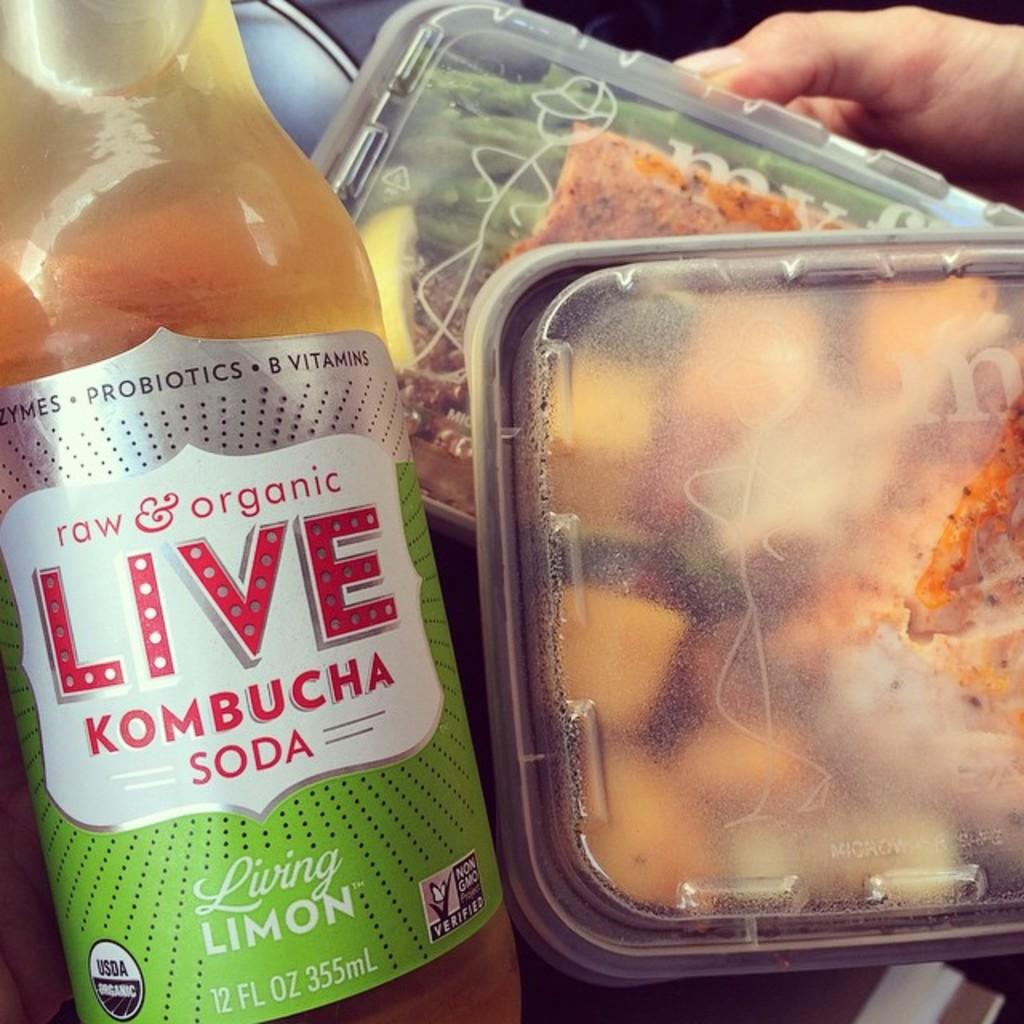<image>
Render a clear and concise summary of the photo. Two containers full of food sit next to a kombucha soda 